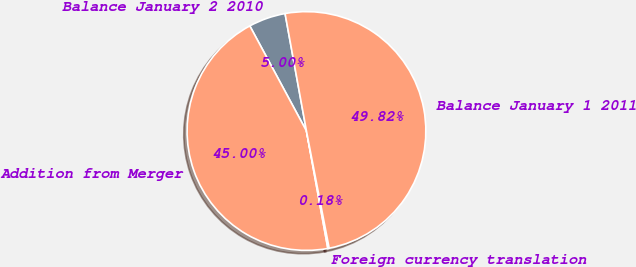Convert chart. <chart><loc_0><loc_0><loc_500><loc_500><pie_chart><fcel>Balance January 2 2010<fcel>Addition from Merger<fcel>Foreign currency translation<fcel>Balance January 1 2011<nl><fcel>5.0%<fcel>45.0%<fcel>0.18%<fcel>49.82%<nl></chart> 